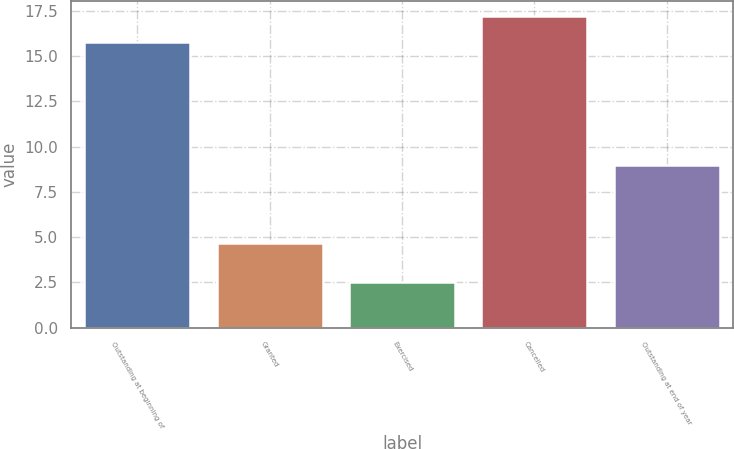Convert chart. <chart><loc_0><loc_0><loc_500><loc_500><bar_chart><fcel>Outstanding at beginning of<fcel>Granted<fcel>Exercised<fcel>Cancelled<fcel>Outstanding at end of year<nl><fcel>15.79<fcel>4.7<fcel>2.55<fcel>17.21<fcel>8.96<nl></chart> 